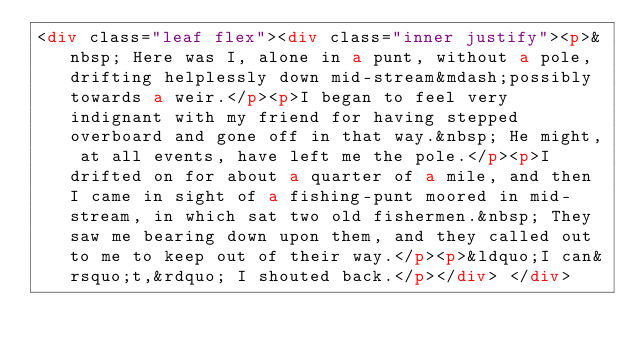<code> <loc_0><loc_0><loc_500><loc_500><_HTML_><div class="leaf flex"><div class="inner justify"><p>&nbsp; Here was I, alone in a punt, without a pole, drifting helplessly down mid-stream&mdash;possibly towards a weir.</p><p>I began to feel very indignant with my friend for having stepped overboard and gone off in that way.&nbsp; He might, at all events, have left me the pole.</p><p>I drifted on for about a quarter of a mile, and then I came in sight of a fishing-punt moored in mid-stream, in which sat two old fishermen.&nbsp; They saw me bearing down upon them, and they called out to me to keep out of their way.</p><p>&ldquo;I can&rsquo;t,&rdquo; I shouted back.</p></div> </div></code> 